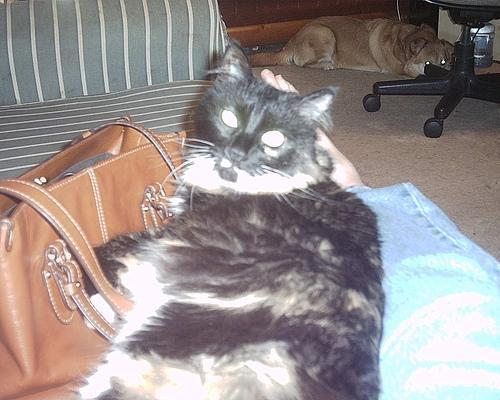What human body part does the cat lean back on?
Select the correct answer and articulate reasoning with the following format: 'Answer: answer
Rationale: rationale.'
Options: Arm, neck, leg, head. Answer: leg.
Rationale: There is a human foot attached to it Why are the animals eyes white?
Choose the right answer and clarify with the format: 'Answer: answer
Rationale: rationale.'
Options: Light reflection, blindness, eye disease, photoshopped. Answer: light reflection.
Rationale: The cat is reflecting the light. 